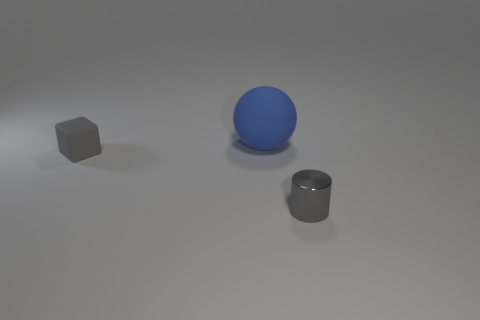Is the material of the small gray thing that is behind the tiny cylinder the same as the small gray thing to the right of the cube?
Offer a terse response. No. There is a object that is the same size as the matte cube; what is its shape?
Offer a terse response. Cylinder. What number of other things are the same color as the small rubber object?
Give a very brief answer. 1. What is the color of the small thing left of the big thing?
Provide a short and direct response. Gray. What number of other things are made of the same material as the small gray cylinder?
Offer a very short reply. 0. Is the number of small things behind the tiny gray metallic object greater than the number of spheres in front of the blue object?
Your answer should be very brief. Yes. There is a big matte sphere; what number of large blue spheres are in front of it?
Ensure brevity in your answer.  0. Are the block and the cylinder that is in front of the blue matte thing made of the same material?
Provide a short and direct response. No. Is there anything else that has the same shape as the blue object?
Give a very brief answer. No. Are the cube and the large blue object made of the same material?
Offer a terse response. Yes. 